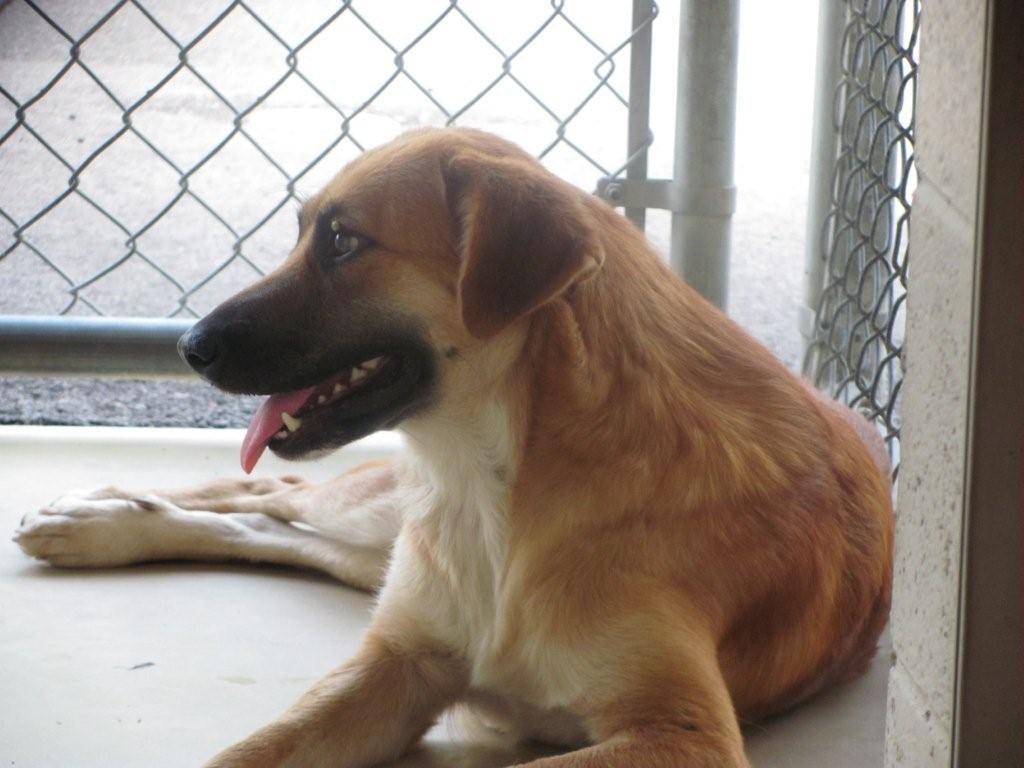How would you summarize this image in a sentence or two? This picture shows a dog and a metal fence the dog is White and Brown in color. 